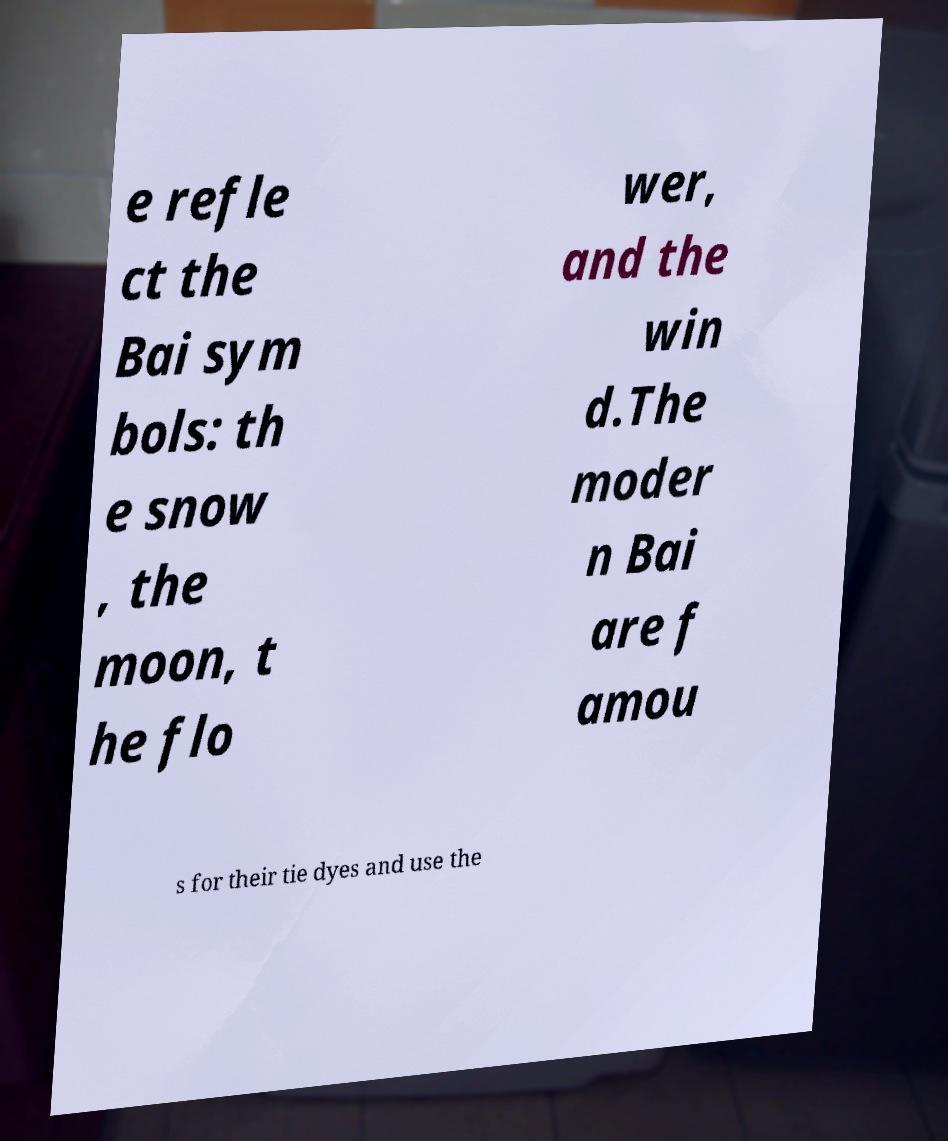Could you extract and type out the text from this image? e refle ct the Bai sym bols: th e snow , the moon, t he flo wer, and the win d.The moder n Bai are f amou s for their tie dyes and use the 